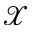Convert formula to latex. <formula><loc_0><loc_0><loc_500><loc_500>\mathcal { X }</formula> 